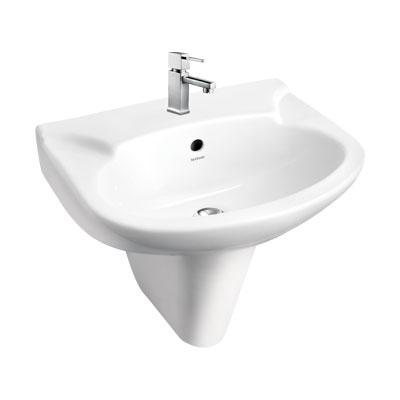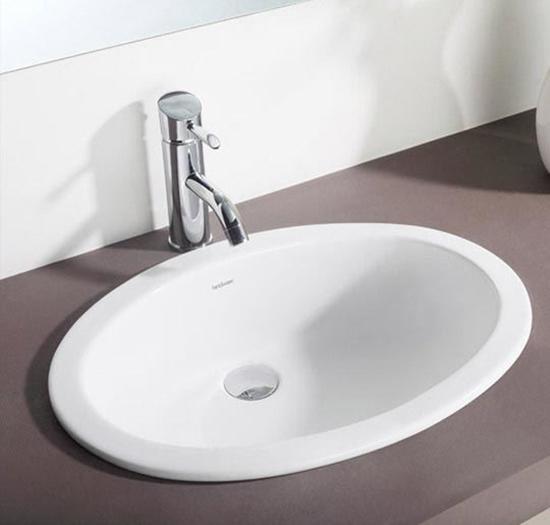The first image is the image on the left, the second image is the image on the right. Examine the images to the left and right. Is the description "One of the sinks is set into a flat counter that is a different color than the sink." accurate? Answer yes or no. Yes. 